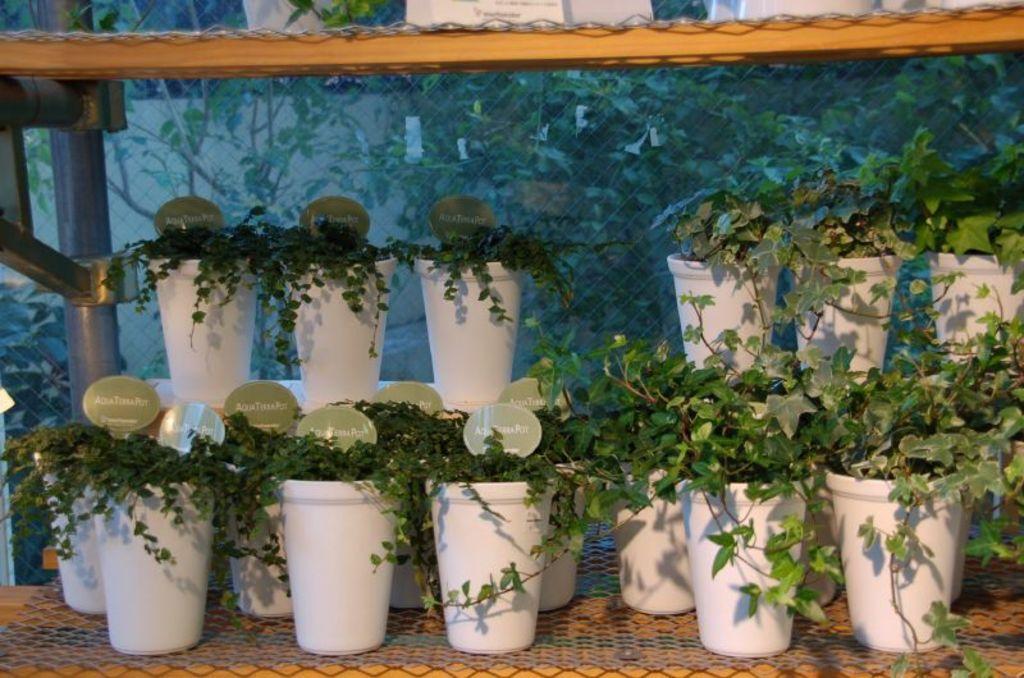Can you describe this image briefly? In the foreground of the picture there are flower pots and plants. On the top there is a wooden object, on it there are flower pot. In the background there are trees and wall. In the center there is a mesh like object and an iron frame. 